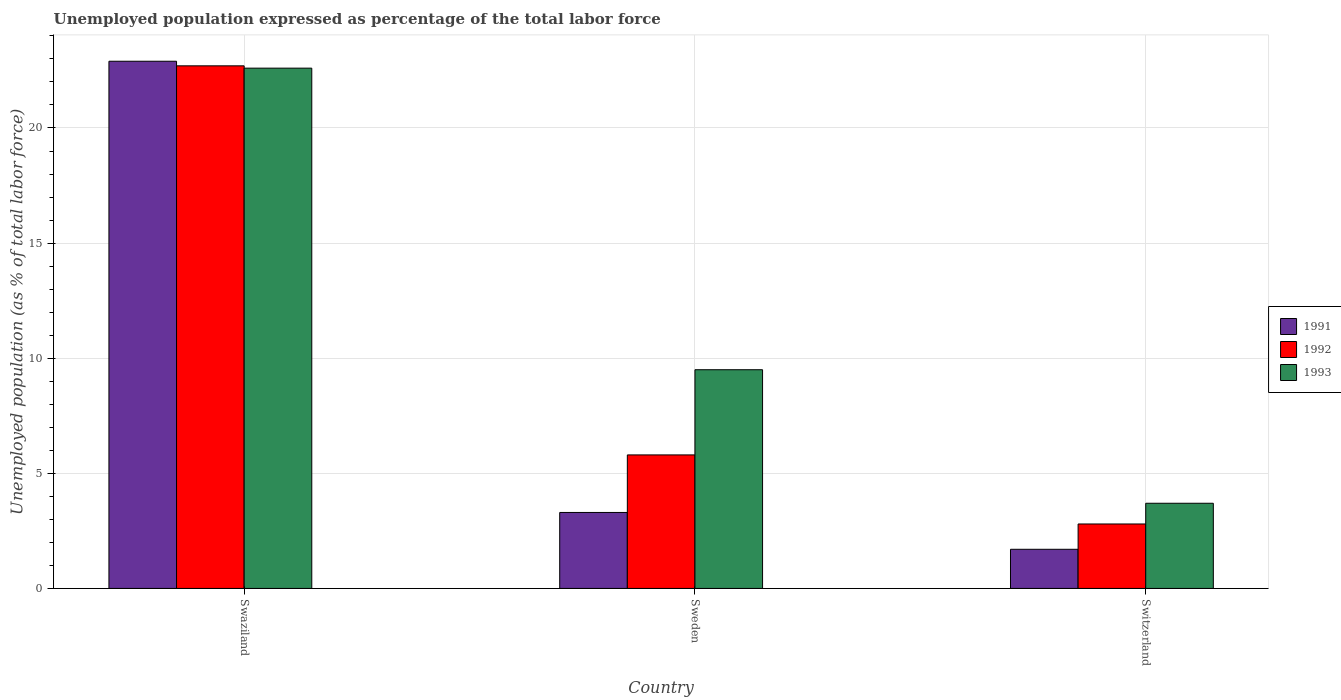How many different coloured bars are there?
Provide a short and direct response. 3. Are the number of bars on each tick of the X-axis equal?
Keep it short and to the point. Yes. How many bars are there on the 3rd tick from the left?
Your response must be concise. 3. How many bars are there on the 2nd tick from the right?
Your response must be concise. 3. What is the label of the 3rd group of bars from the left?
Offer a terse response. Switzerland. In how many cases, is the number of bars for a given country not equal to the number of legend labels?
Keep it short and to the point. 0. What is the unemployment in in 1992 in Sweden?
Your response must be concise. 5.8. Across all countries, what is the maximum unemployment in in 1993?
Give a very brief answer. 22.6. Across all countries, what is the minimum unemployment in in 1992?
Keep it short and to the point. 2.8. In which country was the unemployment in in 1993 maximum?
Provide a succinct answer. Swaziland. In which country was the unemployment in in 1991 minimum?
Offer a terse response. Switzerland. What is the total unemployment in in 1993 in the graph?
Make the answer very short. 35.8. What is the difference between the unemployment in in 1992 in Swaziland and that in Sweden?
Your response must be concise. 16.9. What is the difference between the unemployment in in 1992 in Sweden and the unemployment in in 1991 in Switzerland?
Provide a succinct answer. 4.1. What is the average unemployment in in 1991 per country?
Your answer should be very brief. 9.3. What is the difference between the unemployment in of/in 1991 and unemployment in of/in 1992 in Sweden?
Your answer should be compact. -2.5. In how many countries, is the unemployment in in 1993 greater than 20 %?
Offer a very short reply. 1. What is the ratio of the unemployment in in 1992 in Sweden to that in Switzerland?
Keep it short and to the point. 2.07. What is the difference between the highest and the second highest unemployment in in 1992?
Your response must be concise. -3. What is the difference between the highest and the lowest unemployment in in 1991?
Your response must be concise. 21.2. In how many countries, is the unemployment in in 1993 greater than the average unemployment in in 1993 taken over all countries?
Offer a very short reply. 1. Is the sum of the unemployment in in 1992 in Sweden and Switzerland greater than the maximum unemployment in in 1991 across all countries?
Your answer should be very brief. No. What does the 1st bar from the right in Sweden represents?
Provide a short and direct response. 1993. How many bars are there?
Your answer should be very brief. 9. How many countries are there in the graph?
Keep it short and to the point. 3. Are the values on the major ticks of Y-axis written in scientific E-notation?
Keep it short and to the point. No. Does the graph contain grids?
Your answer should be very brief. Yes. How are the legend labels stacked?
Offer a terse response. Vertical. What is the title of the graph?
Your answer should be very brief. Unemployed population expressed as percentage of the total labor force. What is the label or title of the X-axis?
Keep it short and to the point. Country. What is the label or title of the Y-axis?
Provide a short and direct response. Unemployed population (as % of total labor force). What is the Unemployed population (as % of total labor force) in 1991 in Swaziland?
Make the answer very short. 22.9. What is the Unemployed population (as % of total labor force) in 1992 in Swaziland?
Make the answer very short. 22.7. What is the Unemployed population (as % of total labor force) in 1993 in Swaziland?
Keep it short and to the point. 22.6. What is the Unemployed population (as % of total labor force) in 1991 in Sweden?
Provide a succinct answer. 3.3. What is the Unemployed population (as % of total labor force) in 1992 in Sweden?
Provide a short and direct response. 5.8. What is the Unemployed population (as % of total labor force) of 1991 in Switzerland?
Your response must be concise. 1.7. What is the Unemployed population (as % of total labor force) in 1992 in Switzerland?
Make the answer very short. 2.8. What is the Unemployed population (as % of total labor force) in 1993 in Switzerland?
Make the answer very short. 3.7. Across all countries, what is the maximum Unemployed population (as % of total labor force) in 1991?
Your answer should be very brief. 22.9. Across all countries, what is the maximum Unemployed population (as % of total labor force) of 1992?
Ensure brevity in your answer.  22.7. Across all countries, what is the maximum Unemployed population (as % of total labor force) in 1993?
Give a very brief answer. 22.6. Across all countries, what is the minimum Unemployed population (as % of total labor force) of 1991?
Keep it short and to the point. 1.7. Across all countries, what is the minimum Unemployed population (as % of total labor force) in 1992?
Offer a terse response. 2.8. Across all countries, what is the minimum Unemployed population (as % of total labor force) of 1993?
Provide a short and direct response. 3.7. What is the total Unemployed population (as % of total labor force) of 1991 in the graph?
Offer a very short reply. 27.9. What is the total Unemployed population (as % of total labor force) of 1992 in the graph?
Your answer should be very brief. 31.3. What is the total Unemployed population (as % of total labor force) of 1993 in the graph?
Your response must be concise. 35.8. What is the difference between the Unemployed population (as % of total labor force) in 1991 in Swaziland and that in Sweden?
Offer a very short reply. 19.6. What is the difference between the Unemployed population (as % of total labor force) of 1992 in Swaziland and that in Sweden?
Provide a short and direct response. 16.9. What is the difference between the Unemployed population (as % of total labor force) in 1991 in Swaziland and that in Switzerland?
Provide a succinct answer. 21.2. What is the difference between the Unemployed population (as % of total labor force) in 1992 in Sweden and that in Switzerland?
Your answer should be very brief. 3. What is the difference between the Unemployed population (as % of total labor force) in 1993 in Sweden and that in Switzerland?
Make the answer very short. 5.8. What is the difference between the Unemployed population (as % of total labor force) in 1991 in Swaziland and the Unemployed population (as % of total labor force) in 1992 in Sweden?
Your answer should be very brief. 17.1. What is the difference between the Unemployed population (as % of total labor force) in 1991 in Swaziland and the Unemployed population (as % of total labor force) in 1992 in Switzerland?
Provide a succinct answer. 20.1. What is the difference between the Unemployed population (as % of total labor force) of 1991 in Swaziland and the Unemployed population (as % of total labor force) of 1993 in Switzerland?
Give a very brief answer. 19.2. What is the difference between the Unemployed population (as % of total labor force) of 1992 in Sweden and the Unemployed population (as % of total labor force) of 1993 in Switzerland?
Your answer should be compact. 2.1. What is the average Unemployed population (as % of total labor force) of 1992 per country?
Offer a very short reply. 10.43. What is the average Unemployed population (as % of total labor force) in 1993 per country?
Provide a succinct answer. 11.93. What is the difference between the Unemployed population (as % of total labor force) of 1991 and Unemployed population (as % of total labor force) of 1992 in Swaziland?
Keep it short and to the point. 0.2. What is the difference between the Unemployed population (as % of total labor force) of 1991 and Unemployed population (as % of total labor force) of 1993 in Swaziland?
Make the answer very short. 0.3. What is the difference between the Unemployed population (as % of total labor force) in 1991 and Unemployed population (as % of total labor force) in 1993 in Sweden?
Offer a terse response. -6.2. What is the ratio of the Unemployed population (as % of total labor force) of 1991 in Swaziland to that in Sweden?
Offer a terse response. 6.94. What is the ratio of the Unemployed population (as % of total labor force) of 1992 in Swaziland to that in Sweden?
Your answer should be very brief. 3.91. What is the ratio of the Unemployed population (as % of total labor force) in 1993 in Swaziland to that in Sweden?
Make the answer very short. 2.38. What is the ratio of the Unemployed population (as % of total labor force) in 1991 in Swaziland to that in Switzerland?
Provide a short and direct response. 13.47. What is the ratio of the Unemployed population (as % of total labor force) of 1992 in Swaziland to that in Switzerland?
Provide a succinct answer. 8.11. What is the ratio of the Unemployed population (as % of total labor force) of 1993 in Swaziland to that in Switzerland?
Keep it short and to the point. 6.11. What is the ratio of the Unemployed population (as % of total labor force) of 1991 in Sweden to that in Switzerland?
Provide a succinct answer. 1.94. What is the ratio of the Unemployed population (as % of total labor force) of 1992 in Sweden to that in Switzerland?
Provide a short and direct response. 2.07. What is the ratio of the Unemployed population (as % of total labor force) in 1993 in Sweden to that in Switzerland?
Ensure brevity in your answer.  2.57. What is the difference between the highest and the second highest Unemployed population (as % of total labor force) in 1991?
Make the answer very short. 19.6. What is the difference between the highest and the second highest Unemployed population (as % of total labor force) of 1993?
Your response must be concise. 13.1. What is the difference between the highest and the lowest Unemployed population (as % of total labor force) of 1991?
Your response must be concise. 21.2. What is the difference between the highest and the lowest Unemployed population (as % of total labor force) of 1992?
Keep it short and to the point. 19.9. 